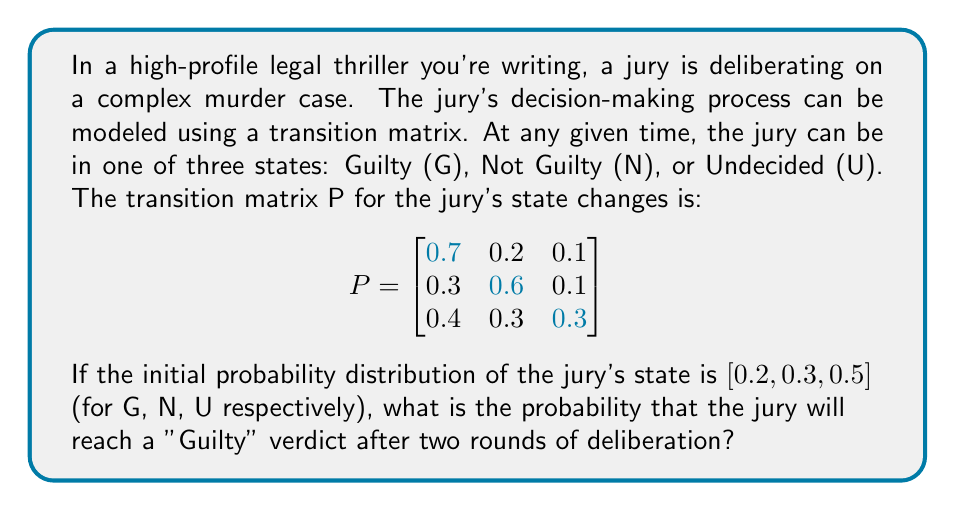Help me with this question. To solve this problem, we need to follow these steps:

1) Let's denote the initial probability distribution as a row vector:
   $$\pi_0 = [0.2, 0.3, 0.5]$$

2) To find the probability distribution after two rounds of deliberation, we need to multiply $\pi_0$ by $P$ twice:
   $$\pi_2 = \pi_0 P^2$$

3) First, let's calculate $P^2$:
   $$P^2 = P \times P = \begin{bmatrix}
   0.7 & 0.2 & 0.1 \\
   0.3 & 0.6 & 0.1 \\
   0.4 & 0.3 & 0.3
   \end{bmatrix} \times \begin{bmatrix}
   0.7 & 0.2 & 0.1 \\
   0.3 & 0.6 & 0.1 \\
   0.4 & 0.3 & 0.3
   \end{bmatrix}$$

4) Multiplying these matrices:
   $$P^2 = \begin{bmatrix}
   0.61 & 0.28 & 0.11 \\
   0.48 & 0.42 & 0.10 \\
   0.52 & 0.33 & 0.15
   \end{bmatrix}$$

5) Now, we multiply $\pi_0$ by $P^2$:
   $$\pi_2 = [0.2, 0.3, 0.5] \times \begin{bmatrix}
   0.61 & 0.28 & 0.11 \\
   0.48 & 0.42 & 0.10 \\
   0.52 & 0.33 & 0.15
   \end{bmatrix}$$

6) Performing this multiplication:
   $$\pi_2 = [0.532, 0.342, 0.126]$$

7) The probability of a "Guilty" verdict after two rounds is the first element of $\pi_2$, which is 0.532 or 53.2%.
Answer: 0.532 